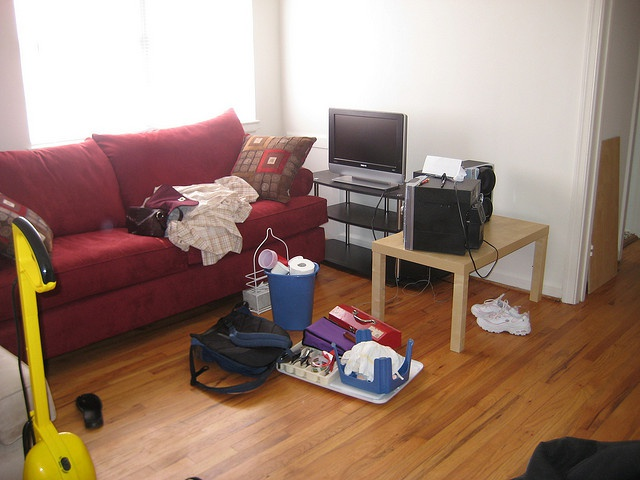Describe the objects in this image and their specific colors. I can see couch in darkgray, maroon, brown, and black tones, backpack in darkgray, black, maroon, and brown tones, tv in darkgray, gray, and black tones, tv in darkgray, black, and gray tones, and handbag in darkgray, black, maroon, and brown tones in this image. 